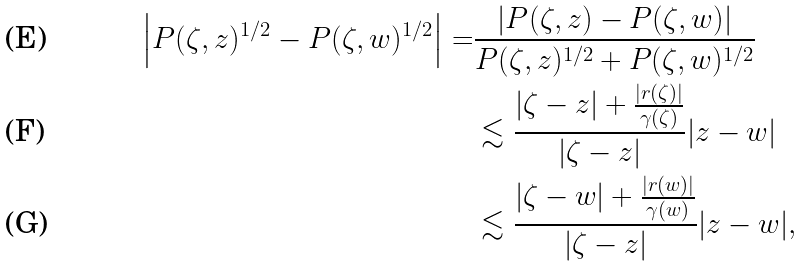Convert formula to latex. <formula><loc_0><loc_0><loc_500><loc_500>\left | P ( \zeta , z ) ^ { 1 / 2 } - P ( \zeta , w ) ^ { 1 / 2 } \right | = & \frac { | P ( \zeta , z ) - P ( \zeta , w ) | } { P ( \zeta , z ) ^ { 1 / 2 } + P ( \zeta , w ) ^ { 1 / 2 } } \\ & \lesssim \frac { | \zeta - z | + \frac { | r ( \zeta ) | } { \gamma ( \zeta ) } } { | \zeta - z | } | z - w | \\ & \lesssim \frac { | \zeta - w | + \frac { | r ( w ) | } { \gamma ( w ) } } { | \zeta - z | } | z - w | ,</formula> 